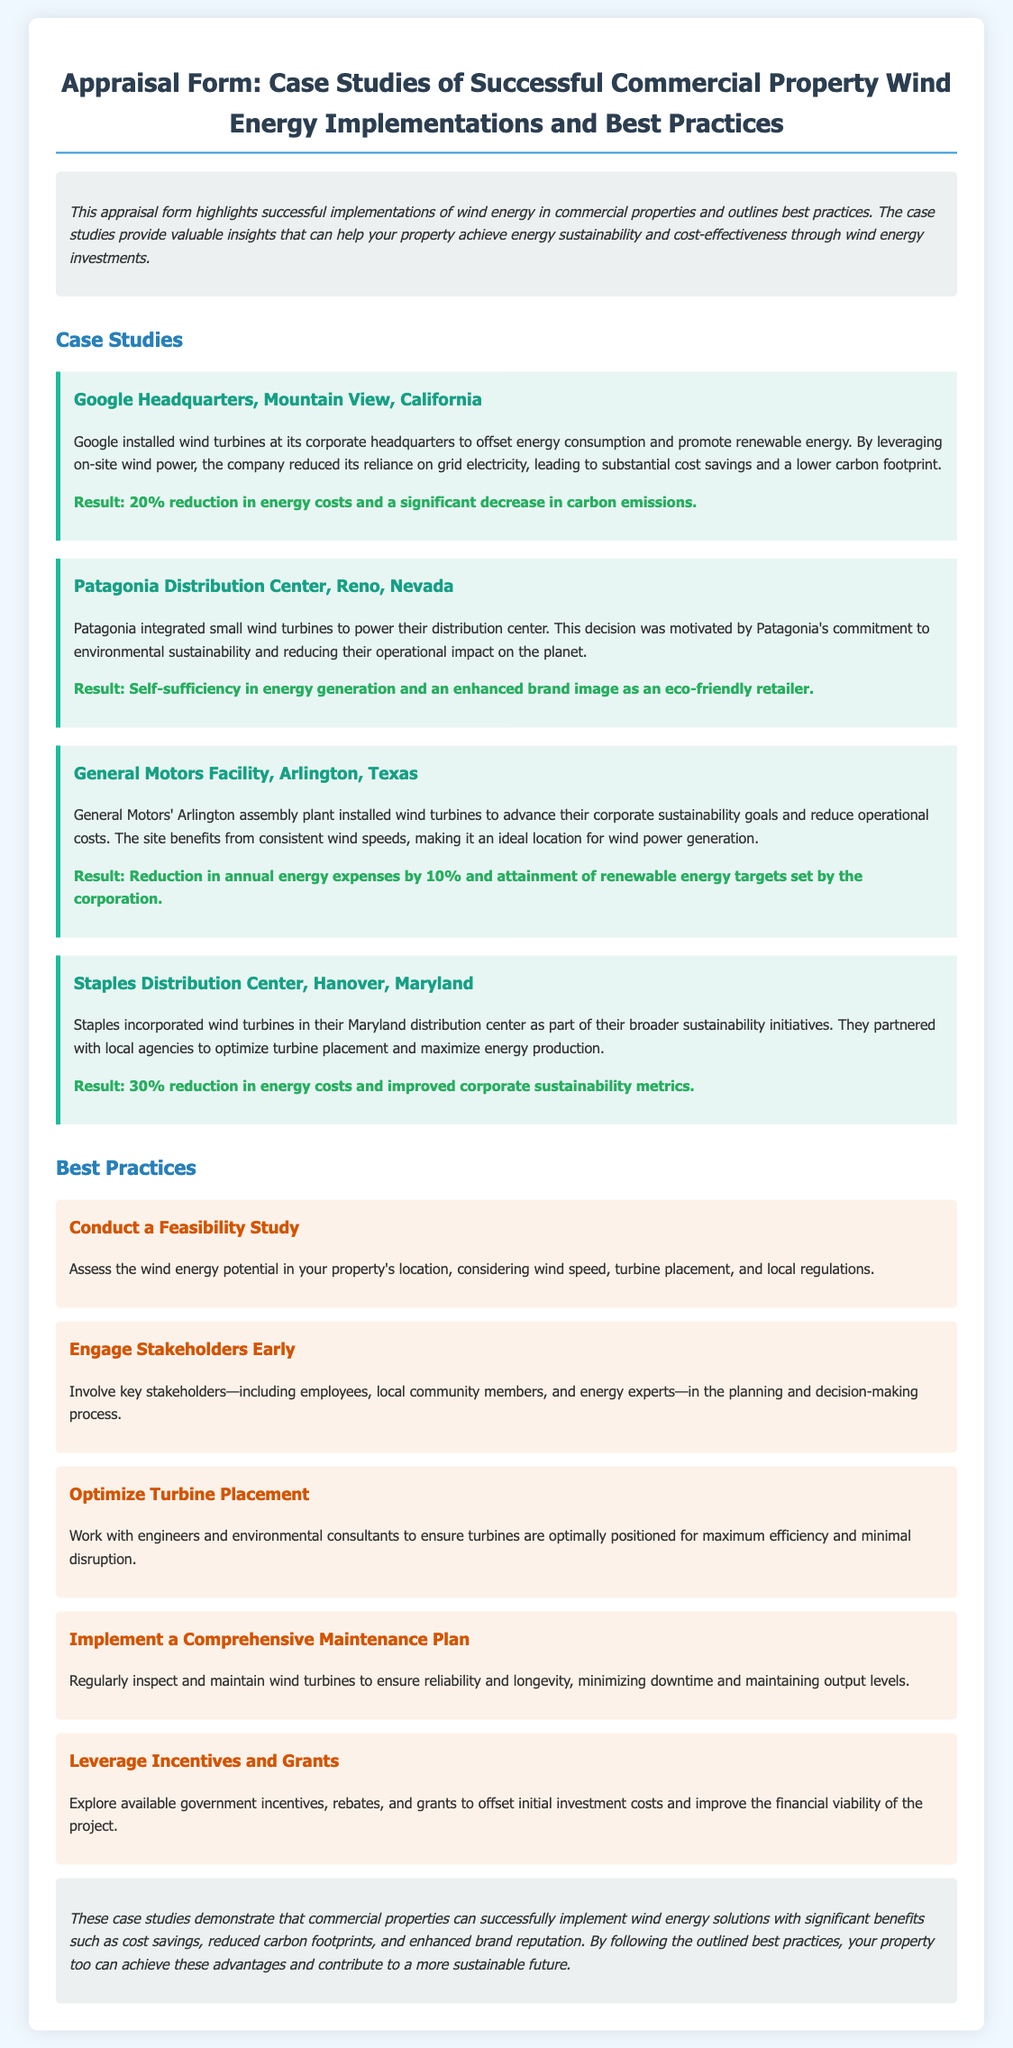what company installed wind turbines at its headquarters in Mountain View? The document states that Google installed wind turbines at its corporate headquarters.
Answer: Google what was the percentage reduction in energy costs at the Google headquarters? The result from the case study indicates a 20% reduction in energy costs.
Answer: 20% which state is the Patagonia Distribution Center located in? The document specifies that Patagonia's distribution center is in Reno, Nevada.
Answer: Nevada what is a key reason for General Motors installing wind turbines at their facility? The document mentions that General Motors aimed to advance their corporate sustainability goals.
Answer: Sustainability what percentage did Staples achieve in energy cost reduction? The document reports a result of a 30% reduction in energy costs for Staples.
Answer: 30% what best practice involves evaluating wind energy potential? The document highlights conducting a feasibility study as a best practice.
Answer: Feasibility Study what should be optimized according to the best practices section? The document advises on optimizing turbine placement for efficiency and minimal disruption.
Answer: Turbine Placement who should be involved early in the planning process? The document suggests engaging stakeholders, including employees and local community members.
Answer: Stakeholders what is the desired outcome of implementing a comprehensive maintenance plan? The document states that the goal is to ensure reliability and longevity of the wind turbines.
Answer: Reliability and Longevity 